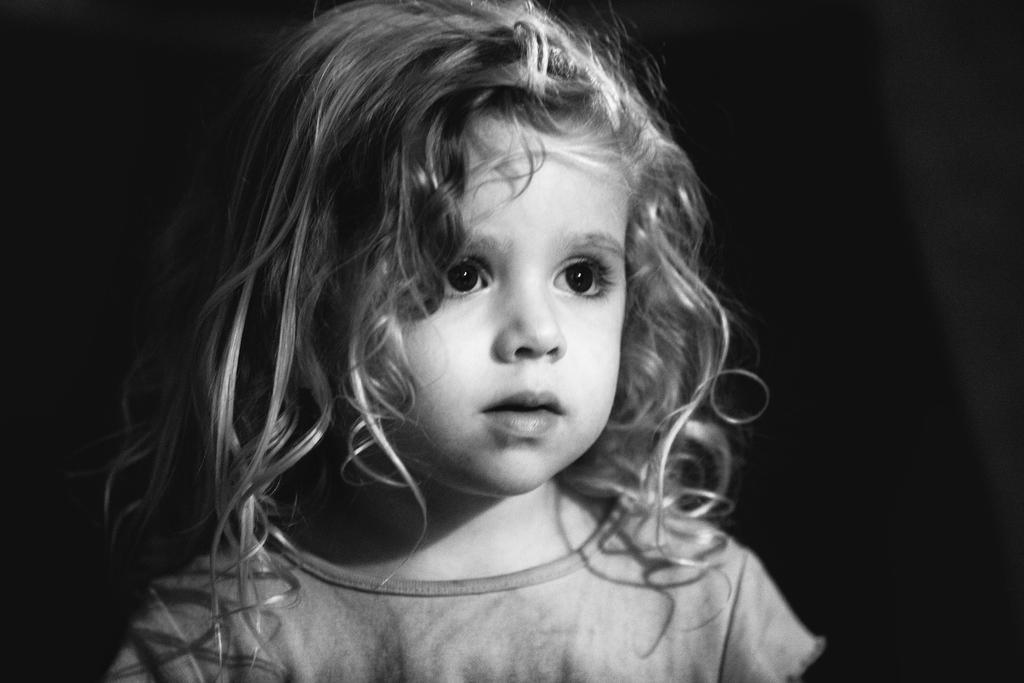Describe this image in one or two sentences. In this image we can see black and white picture of a girl wearing dress. 